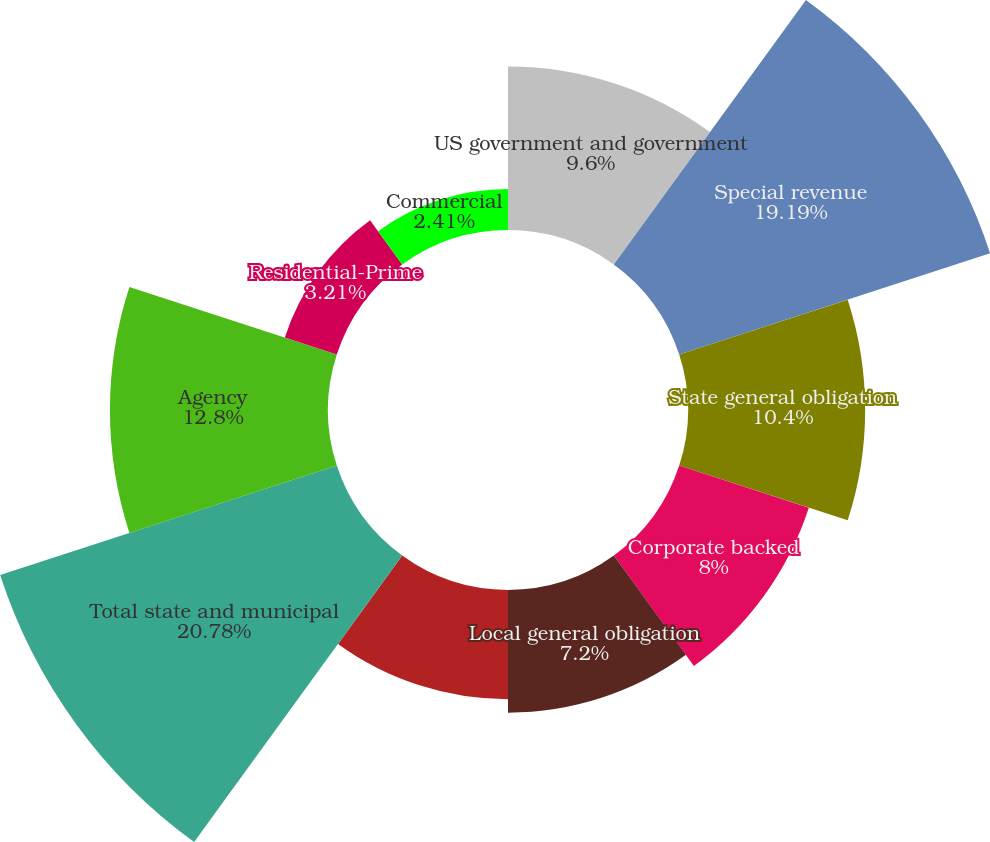Convert chart to OTSL. <chart><loc_0><loc_0><loc_500><loc_500><pie_chart><fcel>US government and government<fcel>Special revenue<fcel>State general obligation<fcel>Corporate backed<fcel>Local general obligation<fcel>Pre-refunded (1)<fcel>Total state and municipal<fcel>Agency<fcel>Residential-Prime<fcel>Commercial<nl><fcel>9.6%<fcel>19.19%<fcel>10.4%<fcel>8.0%<fcel>7.2%<fcel>6.41%<fcel>20.78%<fcel>12.8%<fcel>3.21%<fcel>2.41%<nl></chart> 